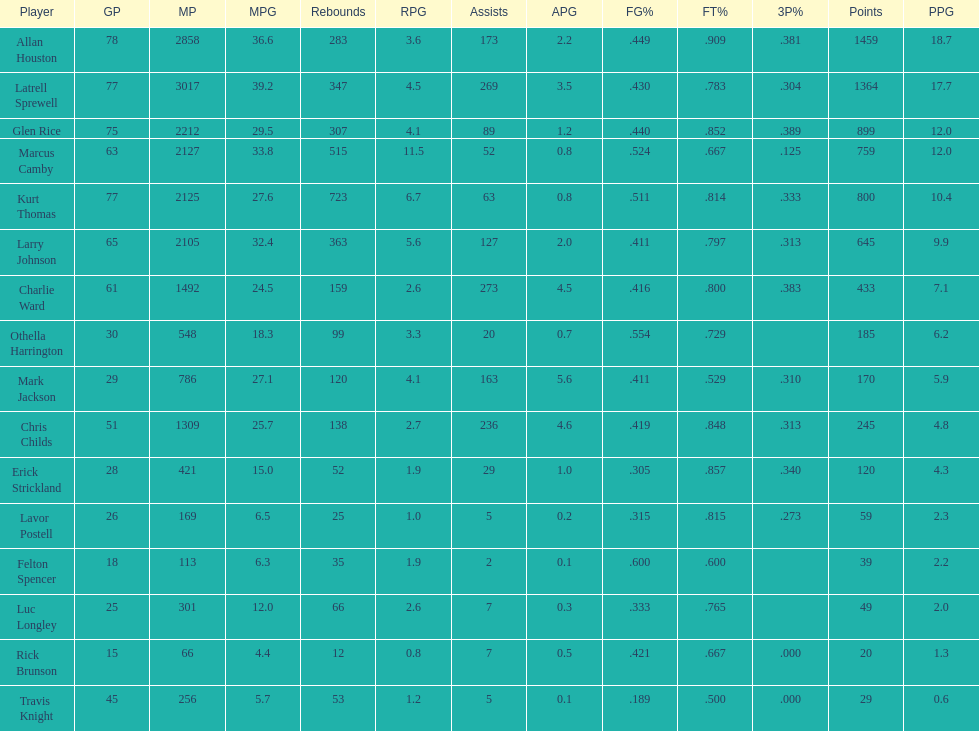Who scored more points, larry johnson or charlie ward? Larry Johnson. 